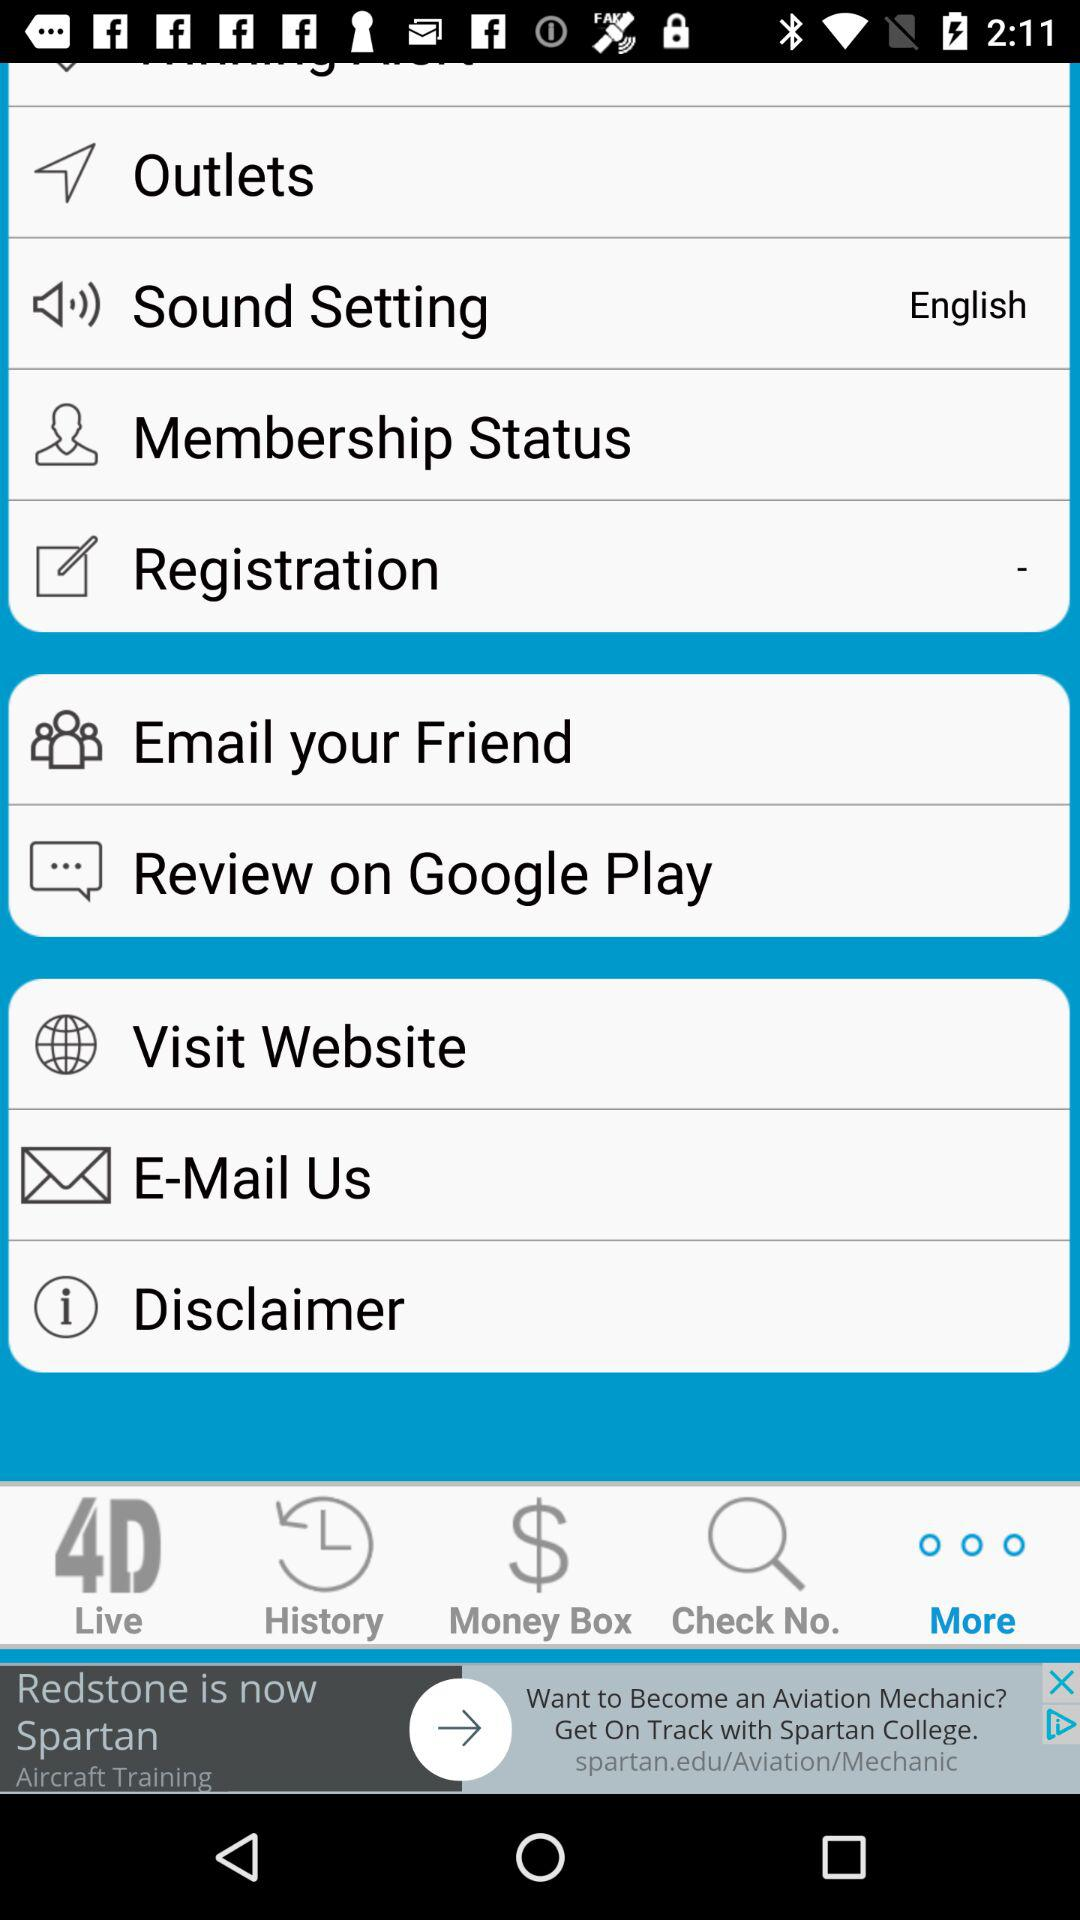What option is selected in "Sound Setting"? The selected option is "English". 